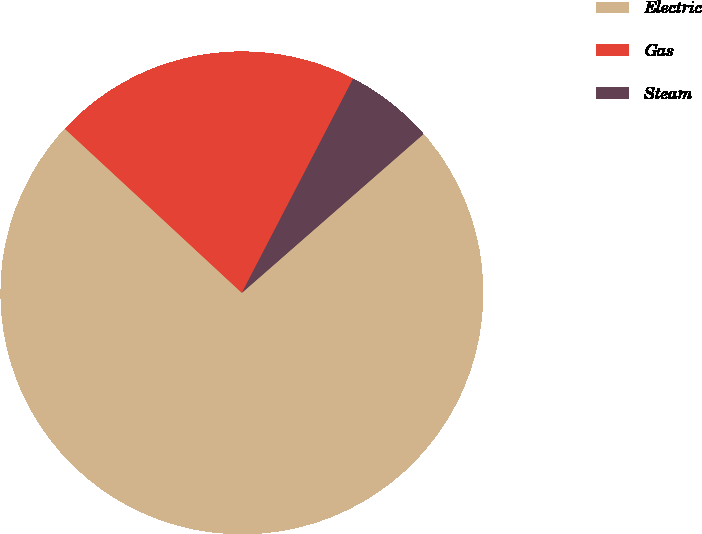<chart> <loc_0><loc_0><loc_500><loc_500><pie_chart><fcel>Electric<fcel>Gas<fcel>Steam<nl><fcel>73.33%<fcel>20.73%<fcel>5.94%<nl></chart> 